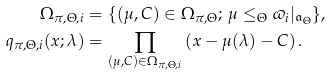Convert formula to latex. <formula><loc_0><loc_0><loc_500><loc_500>\Omega _ { \pi , \Theta , i } & = \{ ( \mu , C ) \in \Omega _ { \pi , \Theta } ; \, \mu \leq _ { \Theta } \varpi _ { i } | _ { \mathfrak a _ { \Theta } } \} , \\ q _ { \pi , \Theta , i } ( x ; \lambda ) & = \prod _ { ( \mu , C ) \in \Omega _ { \pi , \Theta , i } } \left ( x - \mu ( \lambda ) - C \right ) .</formula> 